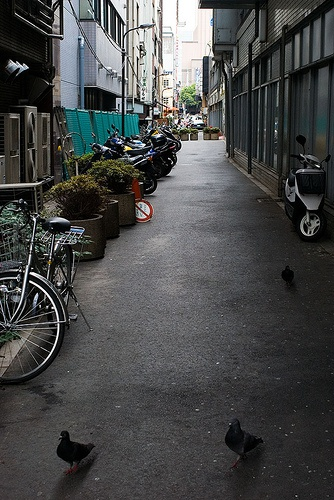Describe the objects in this image and their specific colors. I can see bicycle in black, gray, darkgray, and lightgray tones, potted plant in black, gray, and darkgreen tones, motorcycle in black, gray, darkgray, and purple tones, potted plant in black, darkgreen, gray, and maroon tones, and motorcycle in black, gray, darkgray, and darkgreen tones in this image. 